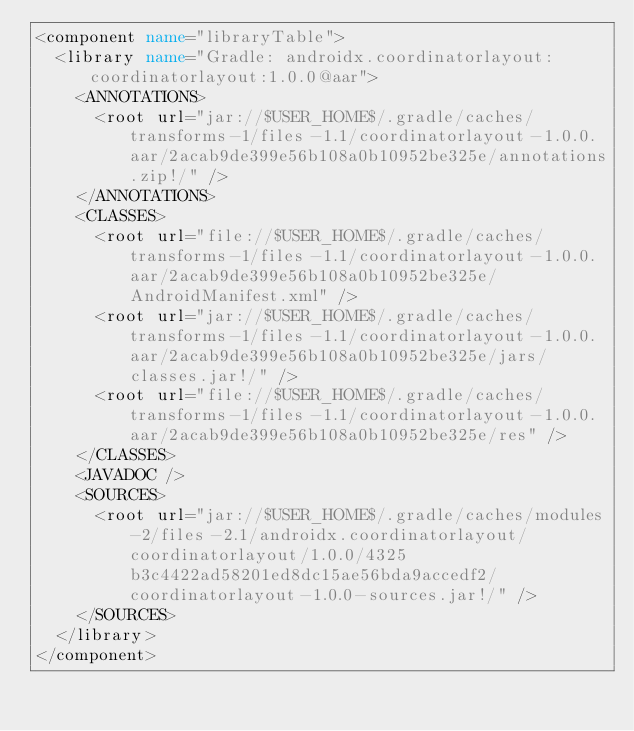Convert code to text. <code><loc_0><loc_0><loc_500><loc_500><_XML_><component name="libraryTable">
  <library name="Gradle: androidx.coordinatorlayout:coordinatorlayout:1.0.0@aar">
    <ANNOTATIONS>
      <root url="jar://$USER_HOME$/.gradle/caches/transforms-1/files-1.1/coordinatorlayout-1.0.0.aar/2acab9de399e56b108a0b10952be325e/annotations.zip!/" />
    </ANNOTATIONS>
    <CLASSES>
      <root url="file://$USER_HOME$/.gradle/caches/transforms-1/files-1.1/coordinatorlayout-1.0.0.aar/2acab9de399e56b108a0b10952be325e/AndroidManifest.xml" />
      <root url="jar://$USER_HOME$/.gradle/caches/transforms-1/files-1.1/coordinatorlayout-1.0.0.aar/2acab9de399e56b108a0b10952be325e/jars/classes.jar!/" />
      <root url="file://$USER_HOME$/.gradle/caches/transforms-1/files-1.1/coordinatorlayout-1.0.0.aar/2acab9de399e56b108a0b10952be325e/res" />
    </CLASSES>
    <JAVADOC />
    <SOURCES>
      <root url="jar://$USER_HOME$/.gradle/caches/modules-2/files-2.1/androidx.coordinatorlayout/coordinatorlayout/1.0.0/4325b3c4422ad58201ed8dc15ae56bda9accedf2/coordinatorlayout-1.0.0-sources.jar!/" />
    </SOURCES>
  </library>
</component></code> 